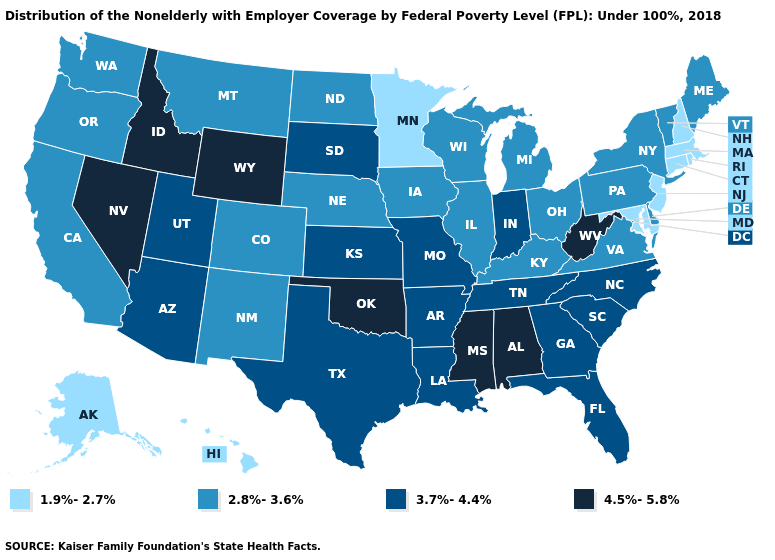Which states have the lowest value in the USA?
Write a very short answer. Alaska, Connecticut, Hawaii, Maryland, Massachusetts, Minnesota, New Hampshire, New Jersey, Rhode Island. What is the value of Nebraska?
Answer briefly. 2.8%-3.6%. Among the states that border North Dakota , which have the highest value?
Short answer required. South Dakota. Which states hav the highest value in the Northeast?
Concise answer only. Maine, New York, Pennsylvania, Vermont. Does the first symbol in the legend represent the smallest category?
Write a very short answer. Yes. What is the value of South Carolina?
Keep it brief. 3.7%-4.4%. Name the states that have a value in the range 4.5%-5.8%?
Keep it brief. Alabama, Idaho, Mississippi, Nevada, Oklahoma, West Virginia, Wyoming. What is the value of Louisiana?
Write a very short answer. 3.7%-4.4%. What is the lowest value in the USA?
Write a very short answer. 1.9%-2.7%. Which states have the highest value in the USA?
Be succinct. Alabama, Idaho, Mississippi, Nevada, Oklahoma, West Virginia, Wyoming. Name the states that have a value in the range 1.9%-2.7%?
Give a very brief answer. Alaska, Connecticut, Hawaii, Maryland, Massachusetts, Minnesota, New Hampshire, New Jersey, Rhode Island. Among the states that border North Carolina , which have the lowest value?
Write a very short answer. Virginia. How many symbols are there in the legend?
Quick response, please. 4. What is the value of Kentucky?
Quick response, please. 2.8%-3.6%. Name the states that have a value in the range 3.7%-4.4%?
Concise answer only. Arizona, Arkansas, Florida, Georgia, Indiana, Kansas, Louisiana, Missouri, North Carolina, South Carolina, South Dakota, Tennessee, Texas, Utah. 